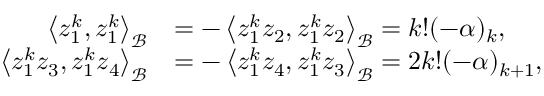Convert formula to latex. <formula><loc_0><loc_0><loc_500><loc_500>\begin{array} { r l } { \left < { z _ { 1 } ^ { k } , z _ { 1 } ^ { k } } \right > _ { \mathcal { B } } } & { = - \left < { z _ { 1 } ^ { k } z _ { 2 } , z _ { 1 } ^ { k } z _ { 2 } } \right > _ { \mathcal { B } } = k ! ( - \alpha ) _ { k } , } \\ { \left < { z _ { 1 } ^ { k } z _ { 3 } , z _ { 1 } ^ { k } z _ { 4 } } \right > _ { \mathcal { B } } } & { = - \left < { z _ { 1 } ^ { k } z _ { 4 } , z _ { 1 } ^ { k } z _ { 3 } } \right > _ { \mathcal { B } } = 2 k ! ( - \alpha ) _ { k + 1 } , } \end{array}</formula> 